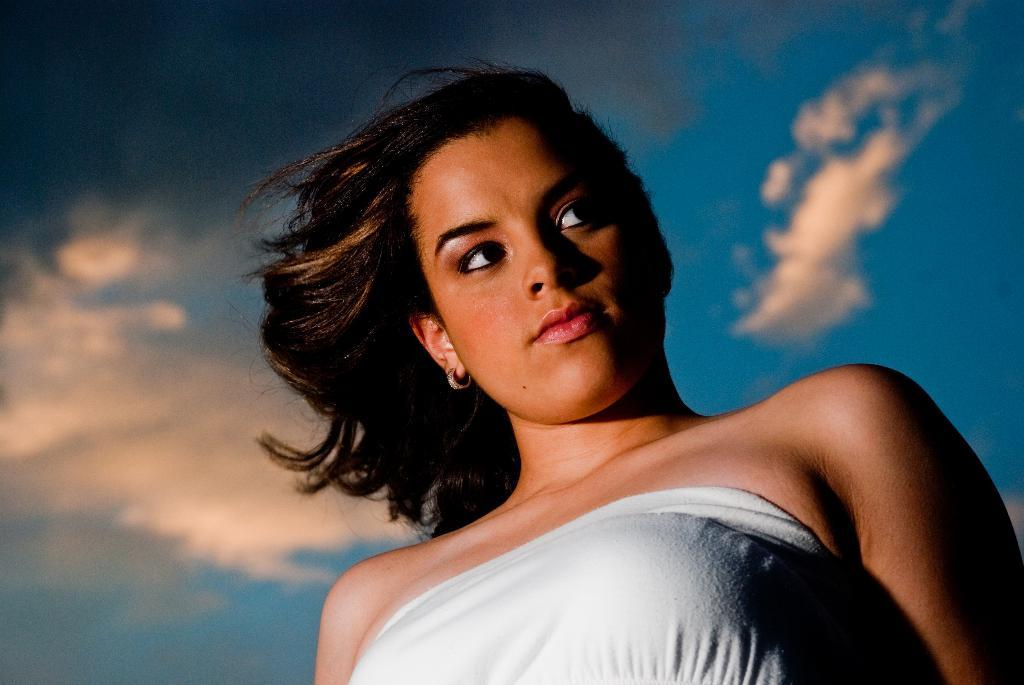Who is present in the image? There is a woman in the picture. What is the condition of the sky in the image? The sky is blue and cloudy. What type of cap is the woman wearing in the image? There is no cap visible in the image; the woman is not wearing any headwear. 